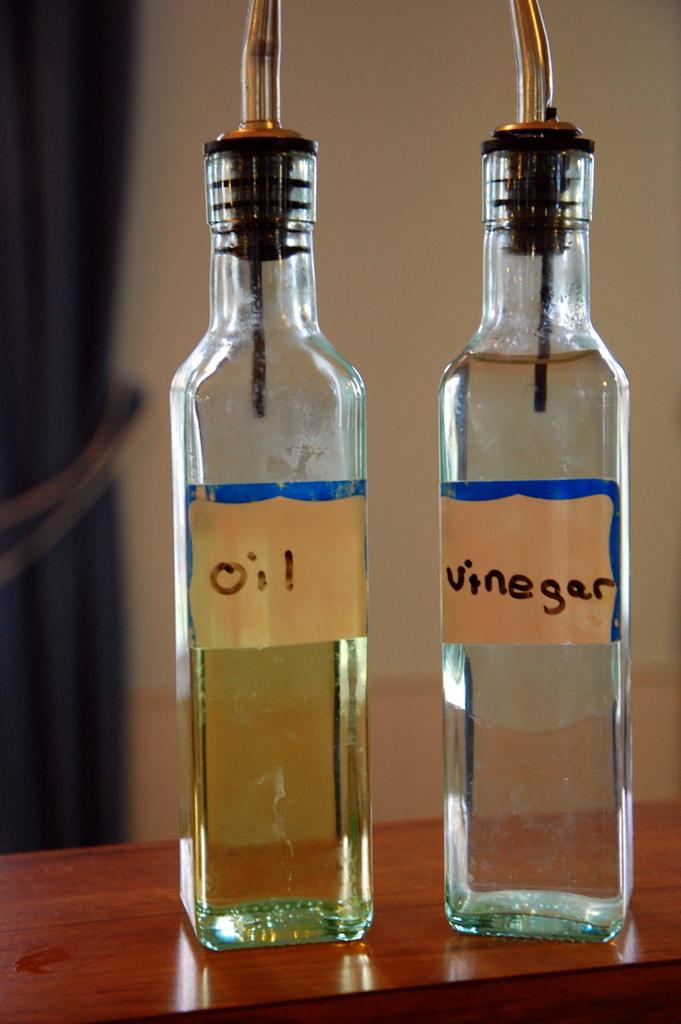How many bottles are on the table in the image? There are two bottles on the table in the image. How many fish are swimming in the plate in the image? There are no fish or plates present in the image; it only features two bottles on a table. 